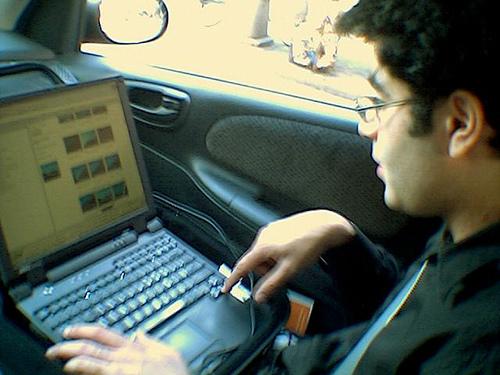Is working the laptop while driving?
Short answer required. No. What is on the boy's face?
Write a very short answer. Glasses. Does the laptop have a qwerty keyboard?
Concise answer only. Yes. 